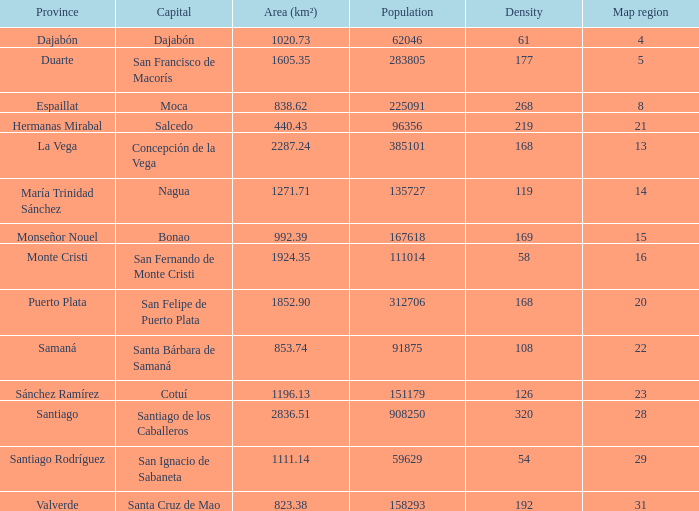14? 1.0. 